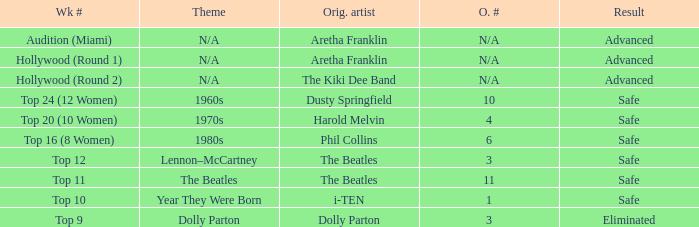What is the order number that has top 20 (10 women)  as the week number? 4.0. 